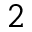<formula> <loc_0><loc_0><loc_500><loc_500>^ { 2 }</formula> 